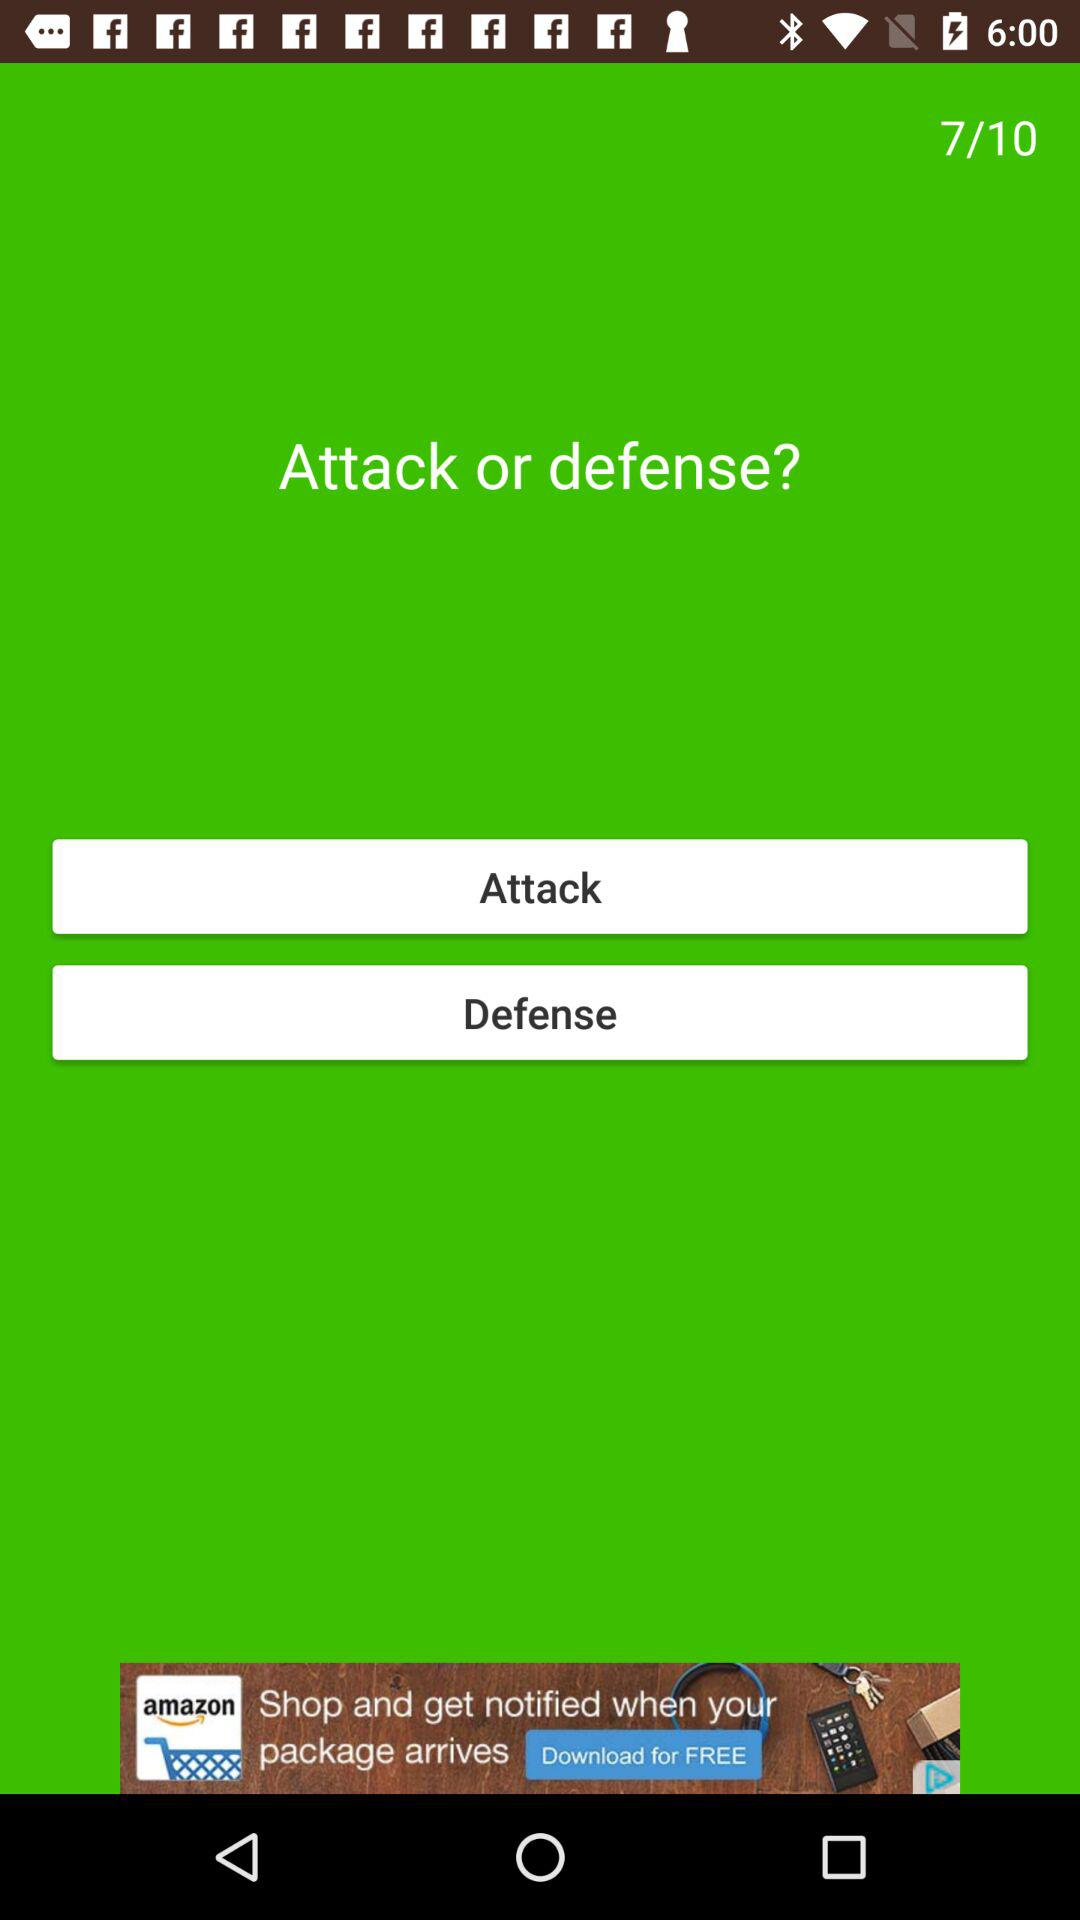How many questions are there? There are 10 questions. 